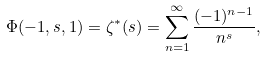Convert formula to latex. <formula><loc_0><loc_0><loc_500><loc_500>\Phi ( - 1 , s , 1 ) = \zeta ^ { \ast } ( s ) = \sum _ { n = 1 } ^ { \infty } \frac { ( - 1 ) ^ { n - 1 } } { n ^ { s } } ,</formula> 